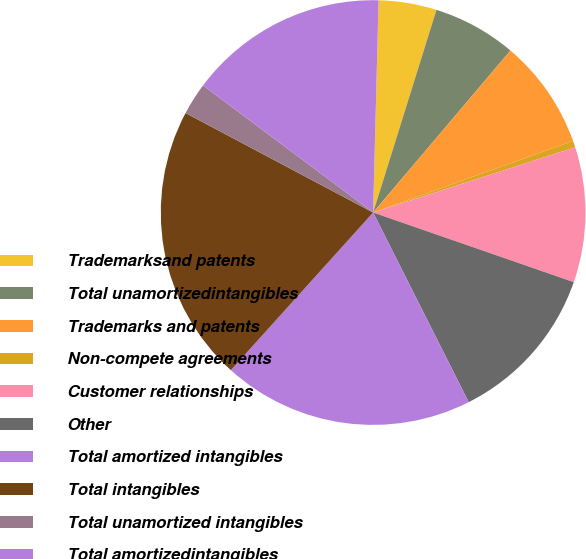<chart> <loc_0><loc_0><loc_500><loc_500><pie_chart><fcel>Trademarksand patents<fcel>Total unamortizedintangibles<fcel>Trademarks and patents<fcel>Non-compete agreements<fcel>Customer relationships<fcel>Other<fcel>Total amortized intangibles<fcel>Total intangibles<fcel>Total unamortized intangibles<fcel>Total amortizedintangibles<nl><fcel>4.41%<fcel>6.37%<fcel>8.33%<fcel>0.5%<fcel>10.29%<fcel>12.25%<fcel>19.11%<fcel>21.07%<fcel>2.45%<fcel>15.19%<nl></chart> 